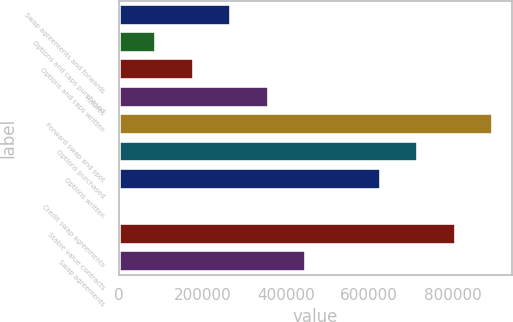Convert chart to OTSL. <chart><loc_0><loc_0><loc_500><loc_500><bar_chart><fcel>Swap agreements and forwards<fcel>Options and caps purchased<fcel>Options and caps written<fcel>Futures<fcel>Forward swap and spot<fcel>Options purchased<fcel>Options written<fcel>Credit swap agreements<fcel>Stable value contracts<fcel>Swap agreements<nl><fcel>269225<fcel>89759.7<fcel>179492<fcel>358958<fcel>897354<fcel>717889<fcel>628156<fcel>27<fcel>807621<fcel>448690<nl></chart> 